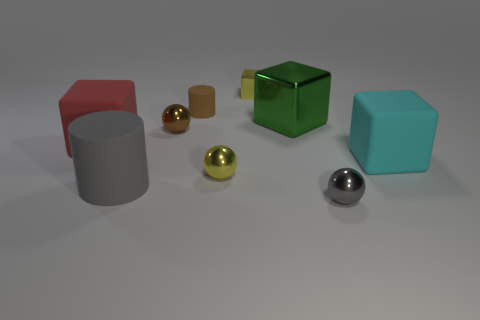There is another block that is made of the same material as the small block; what color is it?
Make the answer very short. Green. Is the number of tiny brown rubber cylinders that are in front of the big cyan rubber block less than the number of big gray matte cylinders right of the big gray cylinder?
Provide a succinct answer. No. How many tiny spheres are the same color as the small metallic block?
Make the answer very short. 1. What is the material of the tiny thing that is the same color as the small cylinder?
Your answer should be very brief. Metal. What number of tiny shiny objects are both in front of the brown matte cylinder and behind the gray ball?
Provide a short and direct response. 2. There is a object right of the ball to the right of the yellow sphere; what is it made of?
Your answer should be very brief. Rubber. Is there a large purple block that has the same material as the cyan object?
Your answer should be very brief. No. What material is the cylinder that is the same size as the red matte cube?
Your response must be concise. Rubber. There is a gray thing to the left of the metal cube that is on the right side of the tiny yellow metallic thing behind the red rubber cube; what size is it?
Offer a terse response. Large. There is a big rubber cylinder in front of the brown cylinder; are there any gray matte cylinders that are to the left of it?
Your answer should be compact. No. 